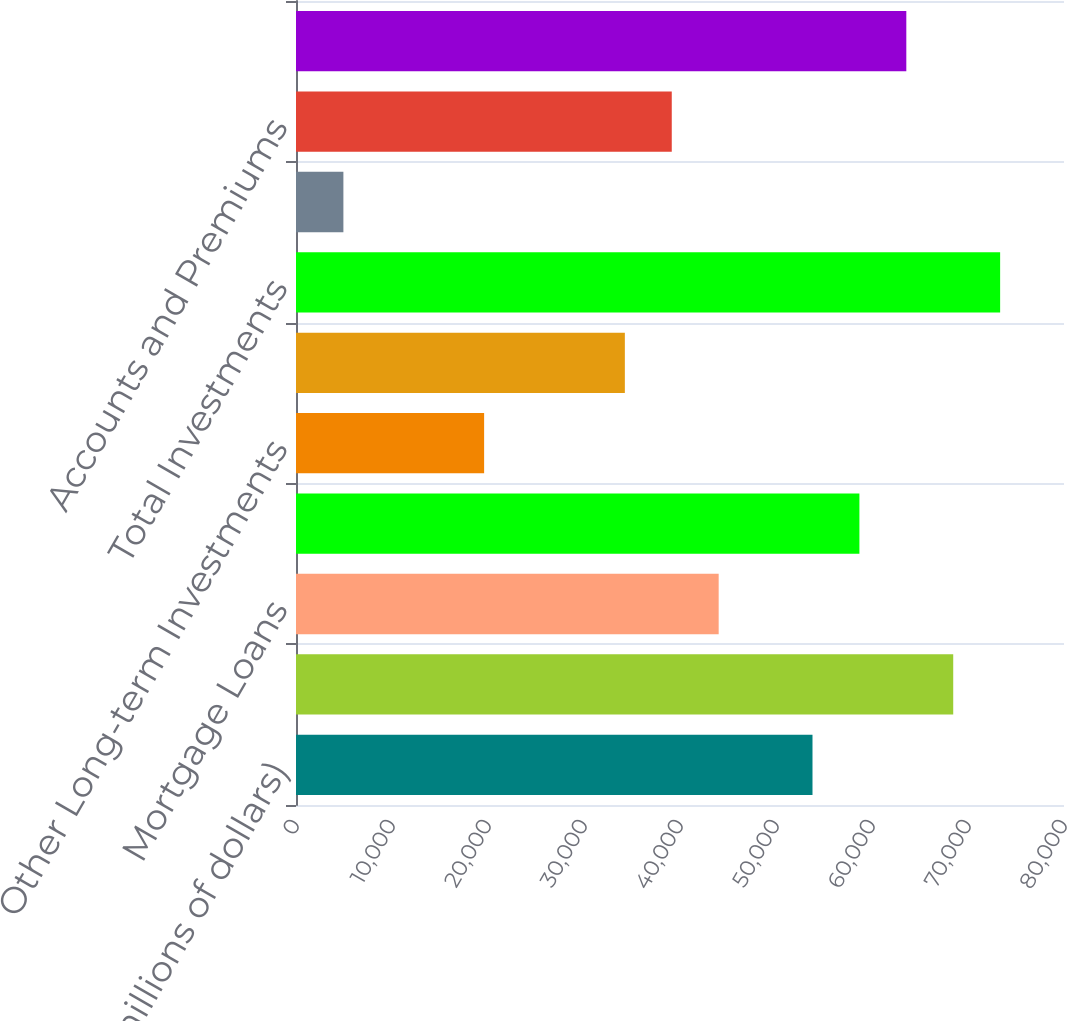Convert chart to OTSL. <chart><loc_0><loc_0><loc_500><loc_500><bar_chart><fcel>(in millions of dollars)<fcel>Fixed Maturity Securities - at<fcel>Mortgage Loans<fcel>Policy Loans<fcel>Other Long-term Investments<fcel>Short-term Investments<fcel>Total Investments<fcel>Cash and Bank Deposits<fcel>Accounts and Premiums<fcel>Reinsurance Recoverable<nl><fcel>53801.4<fcel>68460.7<fcel>44028.4<fcel>58687.8<fcel>19596.1<fcel>34255.5<fcel>73347.2<fcel>4936.76<fcel>39142<fcel>63574.3<nl></chart> 